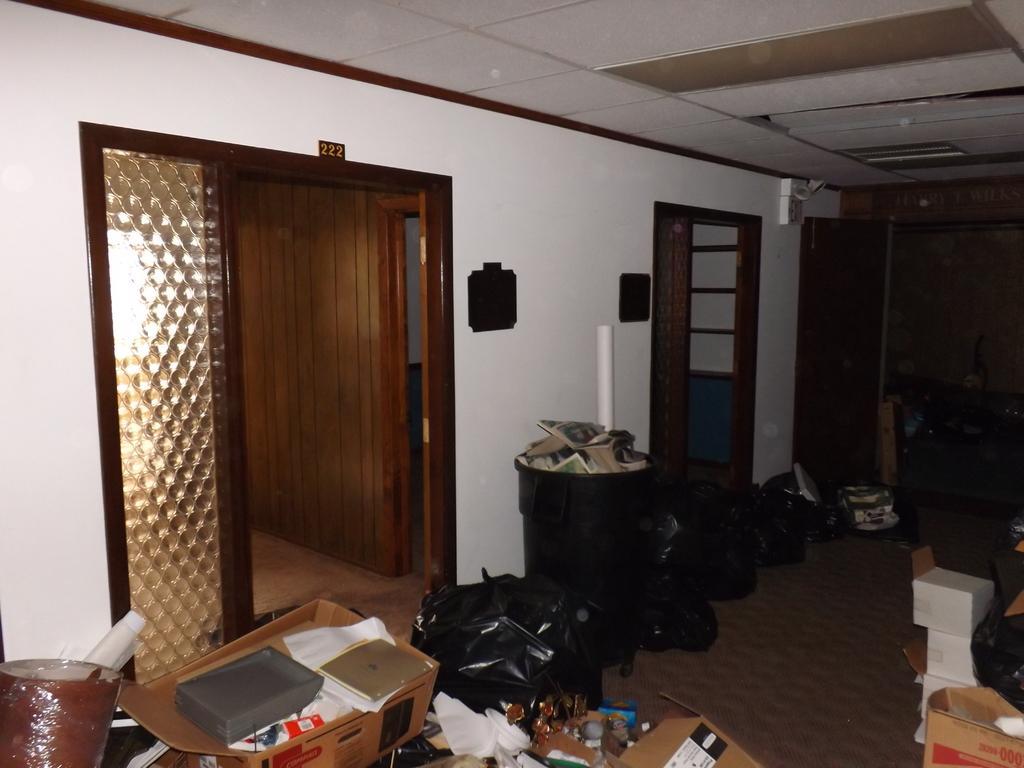In one or two sentences, can you explain what this image depicts? At the top we can see the ceiling. In this picture we can see boxes, objects, number board, wooden wall, black covers and the floor. 